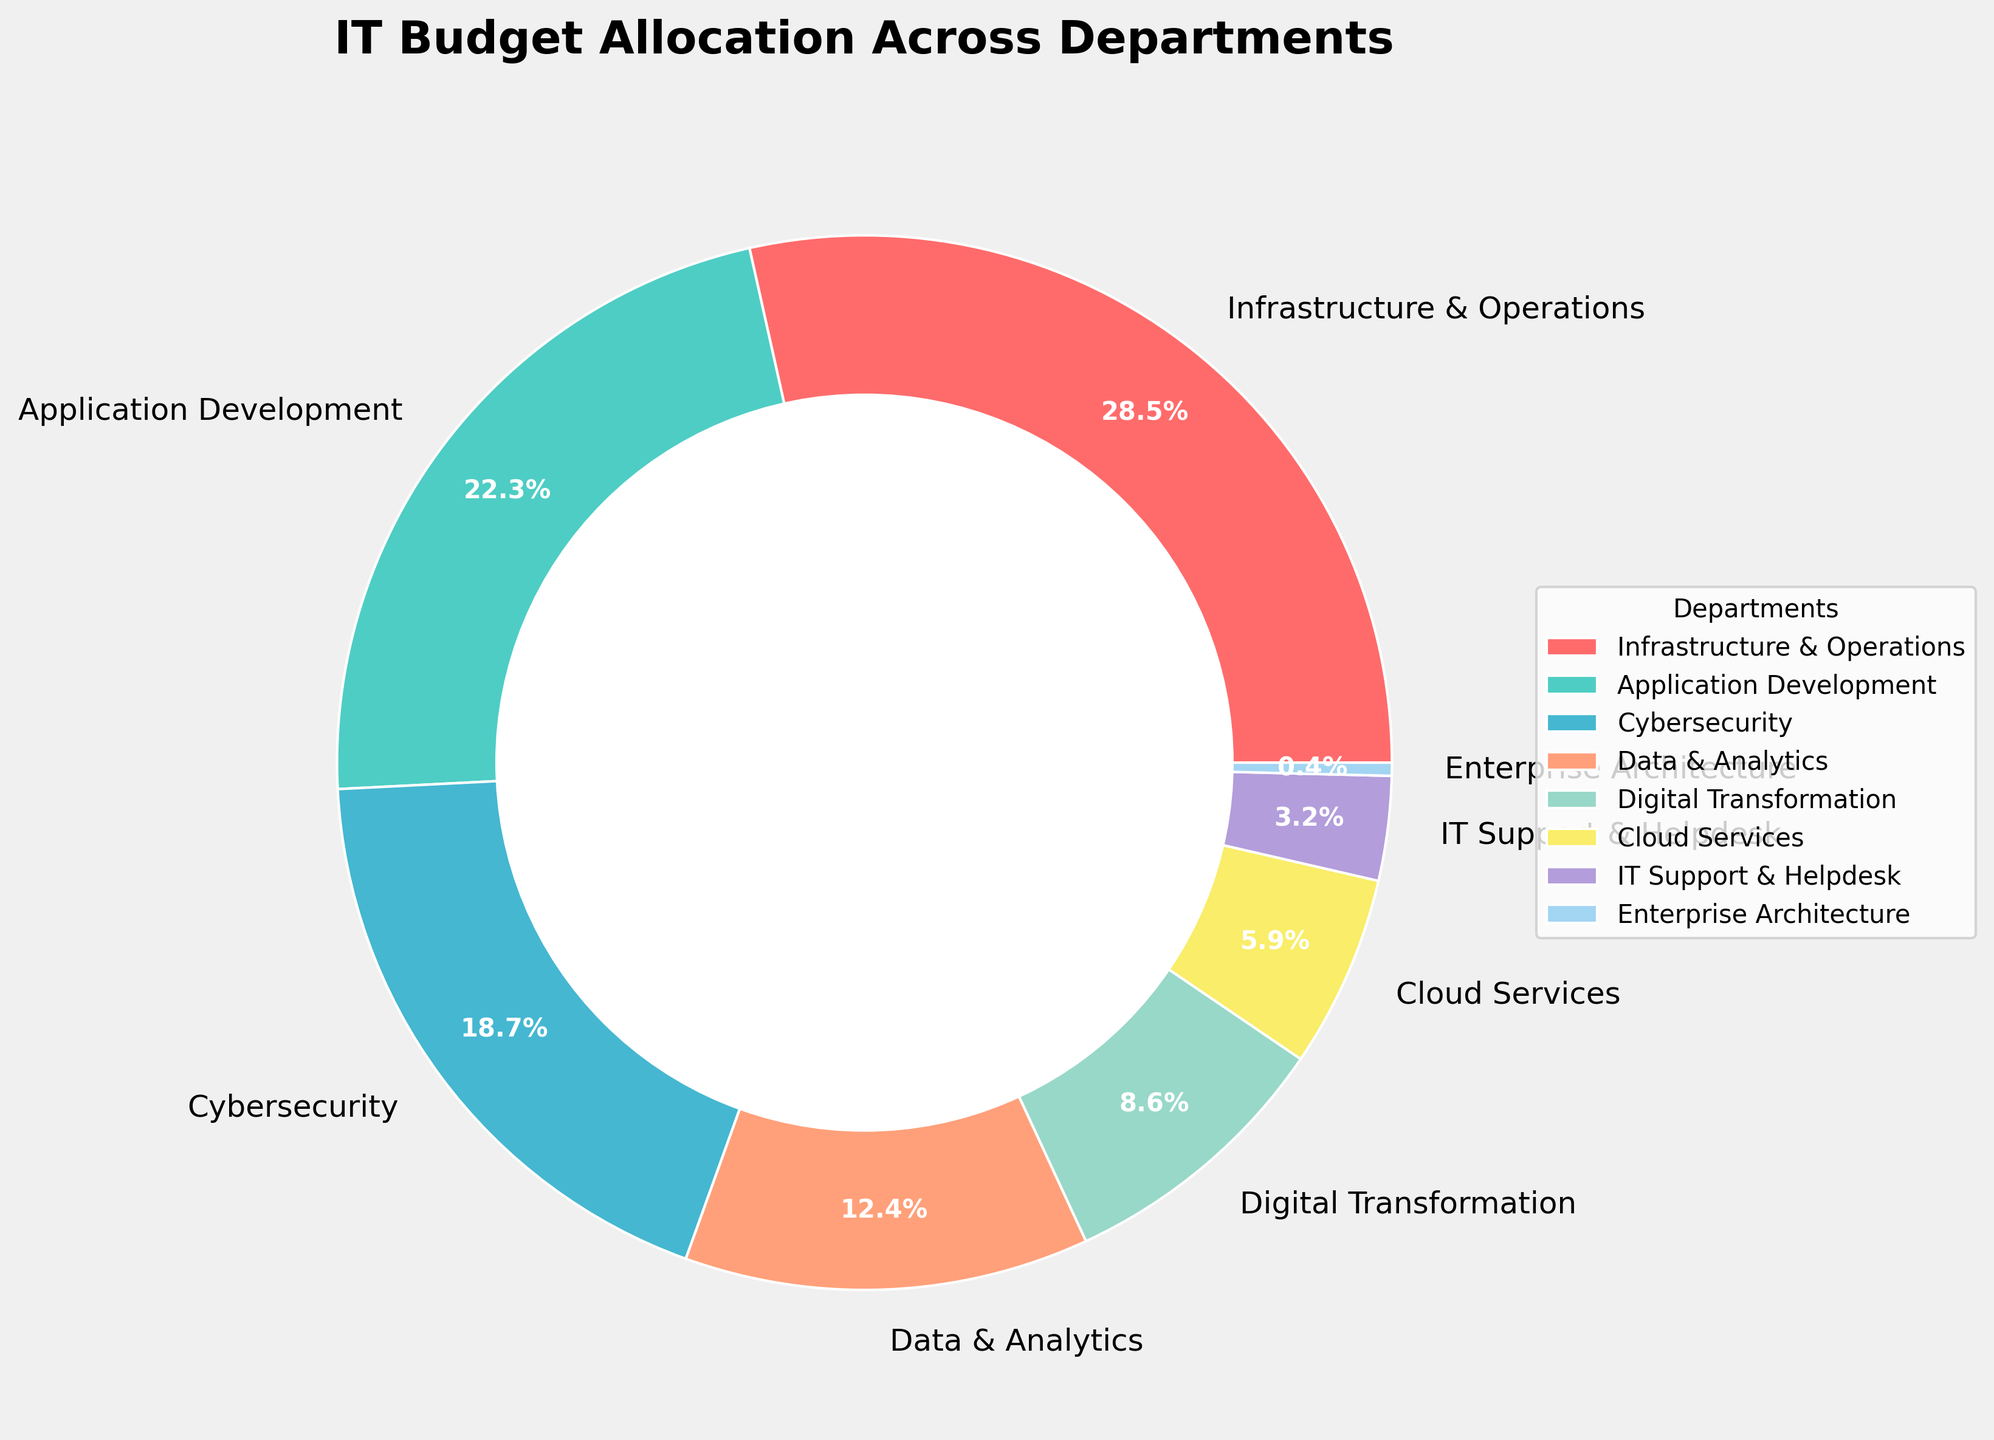Which department has the highest budget allocation percentage? To find the department with the highest budget allocation, refer to the section of the pie chart with the largest slice. This is labeled "Infrastructure & Operations" and has a percentage of 28.5%.
Answer: Infrastructure & Operations How much more percentage is budgeted for Cybersecurity than for Cloud Services? Subtract the percentage for Cloud Services from the percentage for Cybersecurity: 18.7% - 5.9% = 12.8%.
Answer: 12.8% Which two departments have the smallest budget allocations, and what are their combined percentages? Look for the two smallest slices in the pie chart. These are labeled "Enterprise Architecture" (0.4%) and "IT Support & Helpdesk" (3.2%). Adding these percentages together gives 0.4% + 3.2% = 3.6%.
Answer: Enterprise Architecture and IT Support & Helpdesk, 3.6% What is the difference in budget allocation percentages between Application Development and Data & Analytics? Subtract the percentage of Data & Analytics from Application Development: 22.3% - 12.4% = 9.9%.
Answer: 9.9% What is the total percentage allocated to Digital Transformation, Cloud Services, and IT Support & Helpdesk combined? Add the percentages for these three departments: 8.6% + 5.9% + 3.2% = 17.7%.
Answer: 17.7% Which department’s budget allocation is represented by a green slice? The color green corresponds to the first color listed after the red slice, which is assigned to Application Development.
Answer: Application Development How does the budget allocation for Infrastructure & Operations compare to the combined allocation of Data & Analytics and Digital Transformation? First, sum Data & Analytics and Digital Transformation: 12.4% + 8.6% = 21%. Then, compare this to Infrastructure & Operations' 28.5%. Since 28.5% > 21%, Infrastructure & Operations has a higher allocation.
Answer: Higher If we combine the budget allocations of Cybersecurity and Digital Transformation, will this be greater than that of Application Development? Sum the budgets of Cybersecurity and Digital Transformation: 18.7% + 8.6% = 27.3%. Compare this to Application Development's allocation of 22.3%. Since 27.3% > 22.3%, the combined allocation is greater.
Answer: Yes What percentage of the budget is allocated to departments other than Infrastructure & Operations and Application Development? Subtract the sum of Infrastructure & Operations and Application Development from 100%: 100% - (28.5% + 22.3%) = 100% - 50.8% = 49.2%.
Answer: 49.2% Which departments have budget allocations exceeding 10%? Look at the pie chart and note the departments with slices larger than 10%. These are Infrastructure & Operations (28.5%), Application Development (22.3%), Cybersecurity (18.7%), and Data & Analytics (12.4%).
Answer: Infrastructure & Operations, Application Development, Cybersecurity, Data & Analytics 